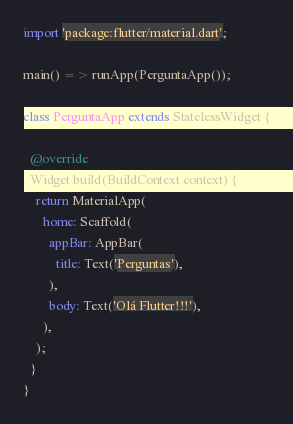Convert code to text. <code><loc_0><loc_0><loc_500><loc_500><_Dart_>import 'package:flutter/material.dart';

main() => runApp(PerguntaApp());

class PerguntaApp extends StatelessWidget {

  @override
  Widget build(BuildContext context) {
    return MaterialApp(
      home: Scaffold(
        appBar: AppBar(
          title: Text('Perguntas'),
        ),
        body: Text('Olá Flutter!!!'),
      ),
    );
  }
}</code> 